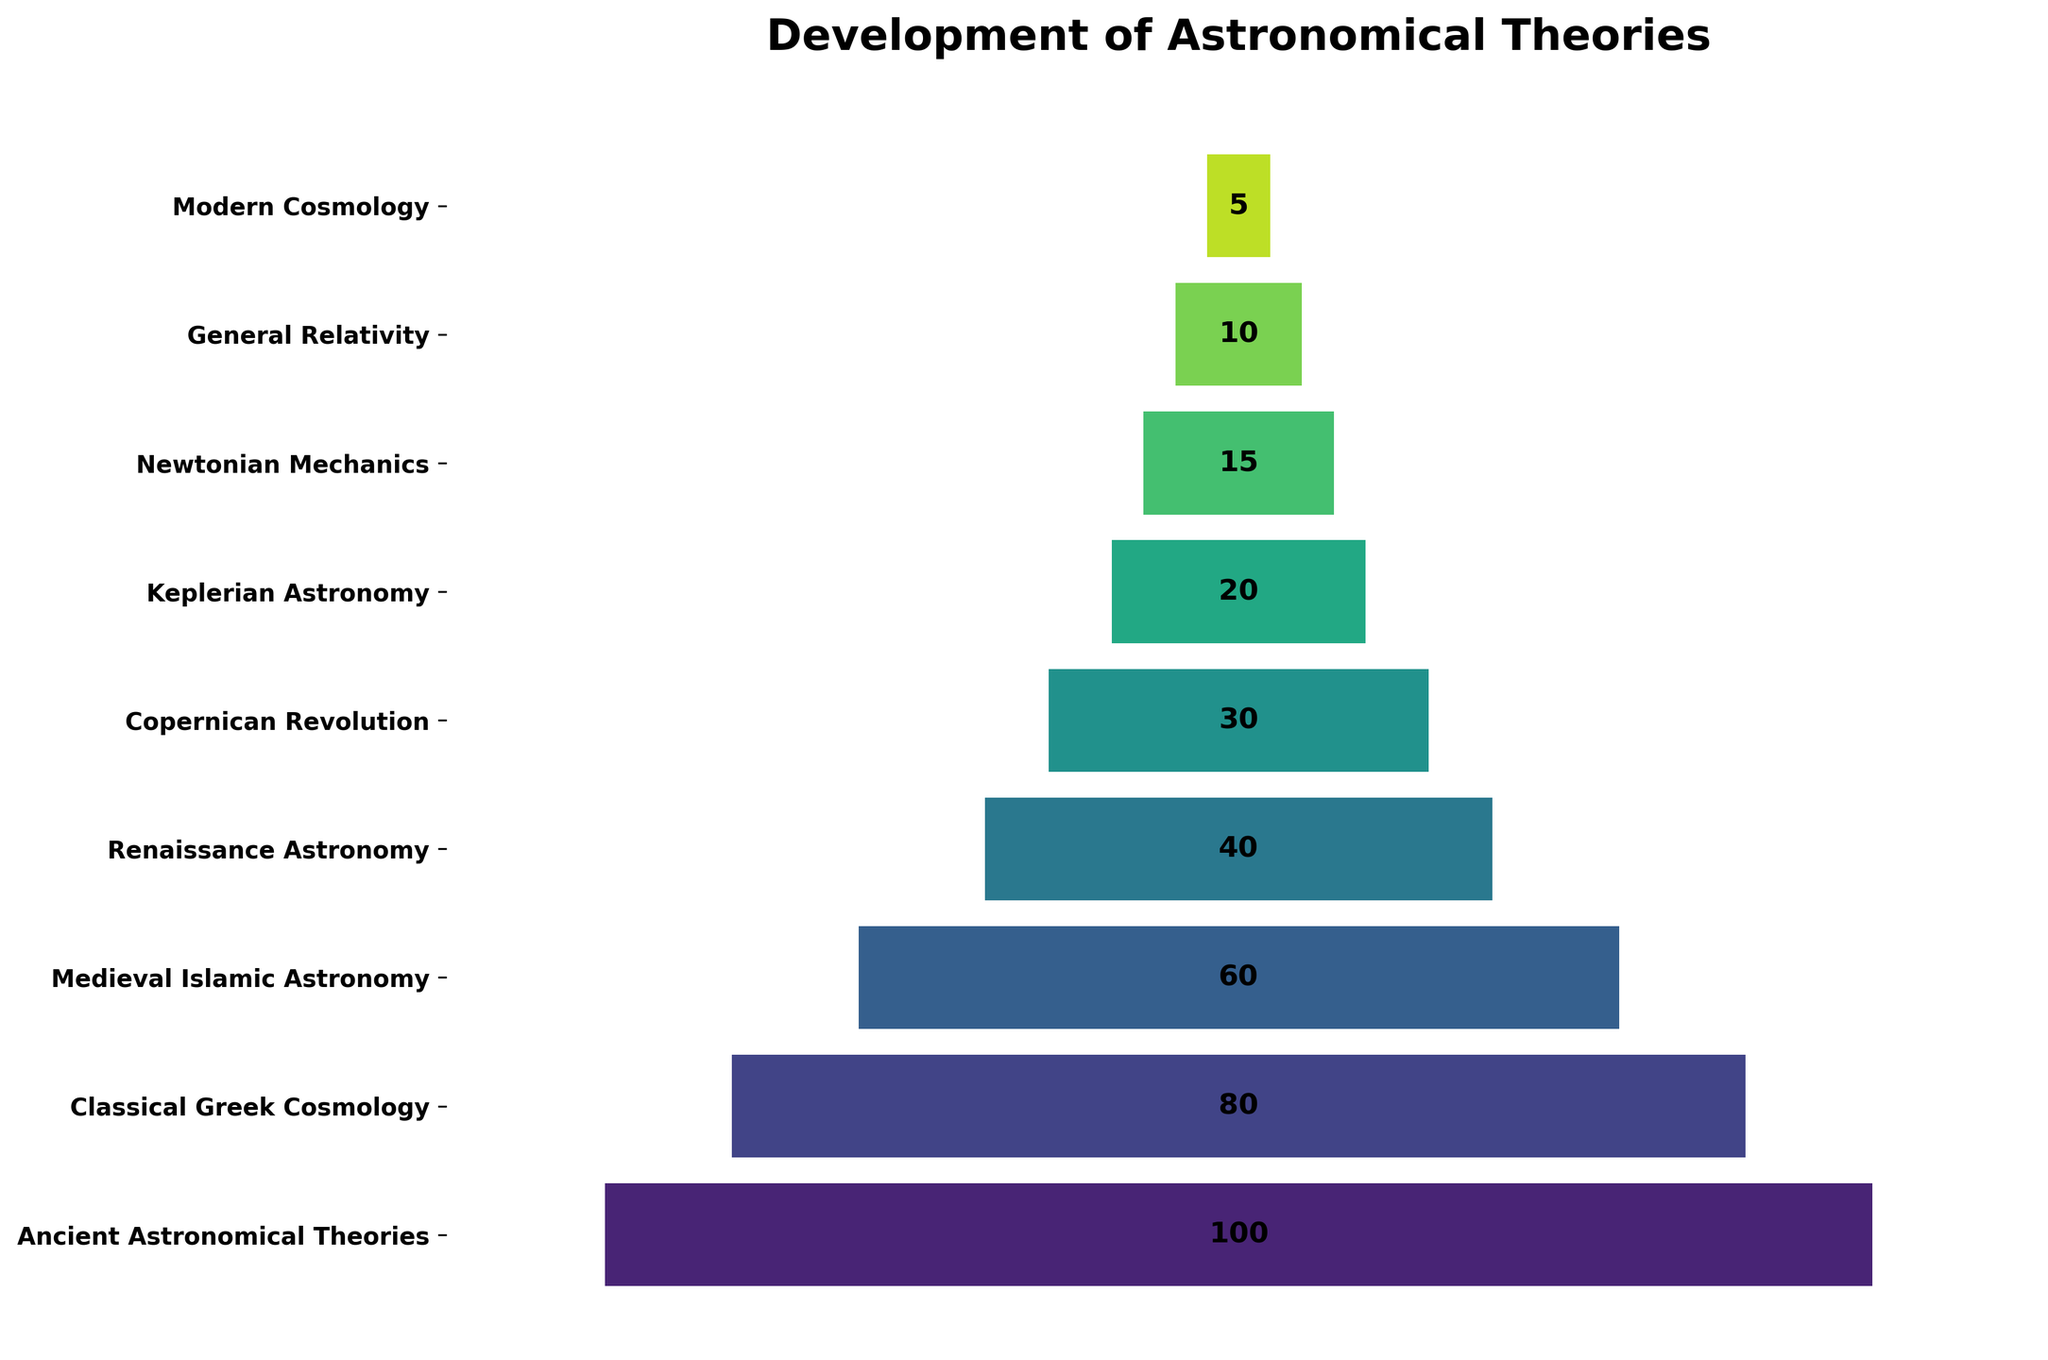what is the title of the figure? The title is prominently displayed at the top of the figure, specifically stating the name of the chart.
Answer: Development of Astronomical Theories What color palette is used for the stages in the chart? The colors used for different stages are derived from the viridis color palette, which varies from shades of green to purple.
Answer: viridis How many stages are depicted in the funnel chart? By counting the number of y-ticks (labels) that represent each stage on the y-axis, you can determine the number of stages.
Answer: 9 Which stage has the highest number of theories? The stage with the widest bar at the top of the funnel chart indicates the highest number of theories.
Answer: Ancient Astronomical Theories What is the number of theories during the Copernican Revolution? By looking at the number displayed at the corresponding position for the Copernican Revolution on the y-axis, you can find the value.
Answer: 30 What is the difference in the number of theories between Renaissance Astronomy and Modern Cosmology? You can calculate the difference by subtracting the number for Modern Cosmology from the number for Renaissance Astronomy (40 - 5).
Answer: 35 What is the average number of theories for Classical Greek Cosmology, Medieval Islamic Astronomy, and Renaissance Astronomy? Sum the numbers of theories for the three stages (80 + 60 + 40) and divide by the number of stages, which is 3. The calculation is (80 + 60 + 40) / 3 = 60.
Answer: 60 Which stage saw a reduction of 45 theories compared to the previous stage? By checking the differences between consecutive stages, you can see Medieval Islamic Astronomy has 60 theories, following Classical Greek Cosmology with 80 theories, giving a reduction of 20 theories. By checking for all, the Renaissance Astronomy from Medieval Islamic Astronomy saw a reduction of 20 theories.
Answer: Medieval Islamic Astronomy How much narrower is the bar for General Relativity compared to Renaissance Astronomy? Find the difference in the number of theories between the two stages, which is
Answer: 30 Which stage has fewer theories: Keplerian Astronomy or Newtonian Mechanics? Comparing the number of theories for each stage, Keplerian Astronomy has 20, and Newtonian Mechanics has 15.
Answer: Newtonian Mechanics 